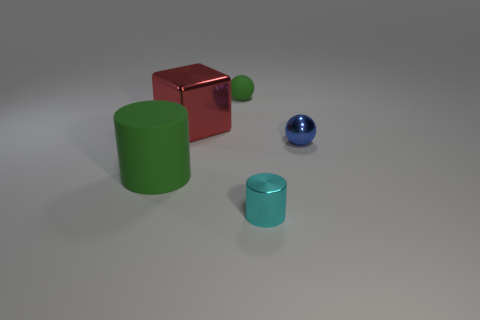Is there anything else that is the same material as the small green sphere?
Give a very brief answer. Yes. The metallic thing that is behind the green cylinder and in front of the large red metal cube has what shape?
Your response must be concise. Sphere. How many things are either rubber objects on the left side of the red metallic block or green things that are in front of the tiny green thing?
Ensure brevity in your answer.  1. How many other things are the same size as the cyan metal cylinder?
Keep it short and to the point. 2. Do the tiny thing that is in front of the big green object and the metal ball have the same color?
Your response must be concise. No. What size is the metal object that is both in front of the red metallic cube and behind the tiny cyan cylinder?
Keep it short and to the point. Small. What number of large objects are rubber cylinders or cyan metallic cylinders?
Your response must be concise. 1. What is the shape of the tiny metallic thing on the right side of the cyan shiny object?
Give a very brief answer. Sphere. What number of blue spheres are there?
Provide a short and direct response. 1. Is the material of the cyan cylinder the same as the small blue ball?
Make the answer very short. Yes. 